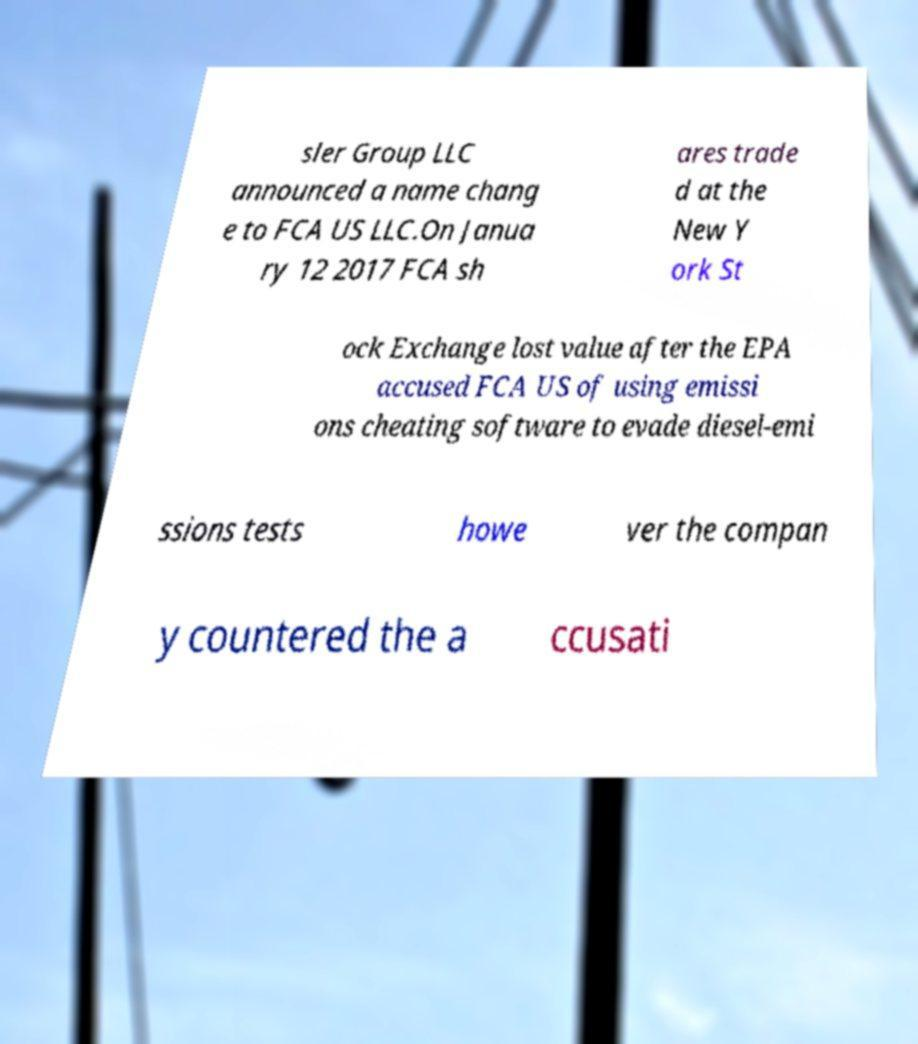I need the written content from this picture converted into text. Can you do that? sler Group LLC announced a name chang e to FCA US LLC.On Janua ry 12 2017 FCA sh ares trade d at the New Y ork St ock Exchange lost value after the EPA accused FCA US of using emissi ons cheating software to evade diesel-emi ssions tests howe ver the compan y countered the a ccusati 